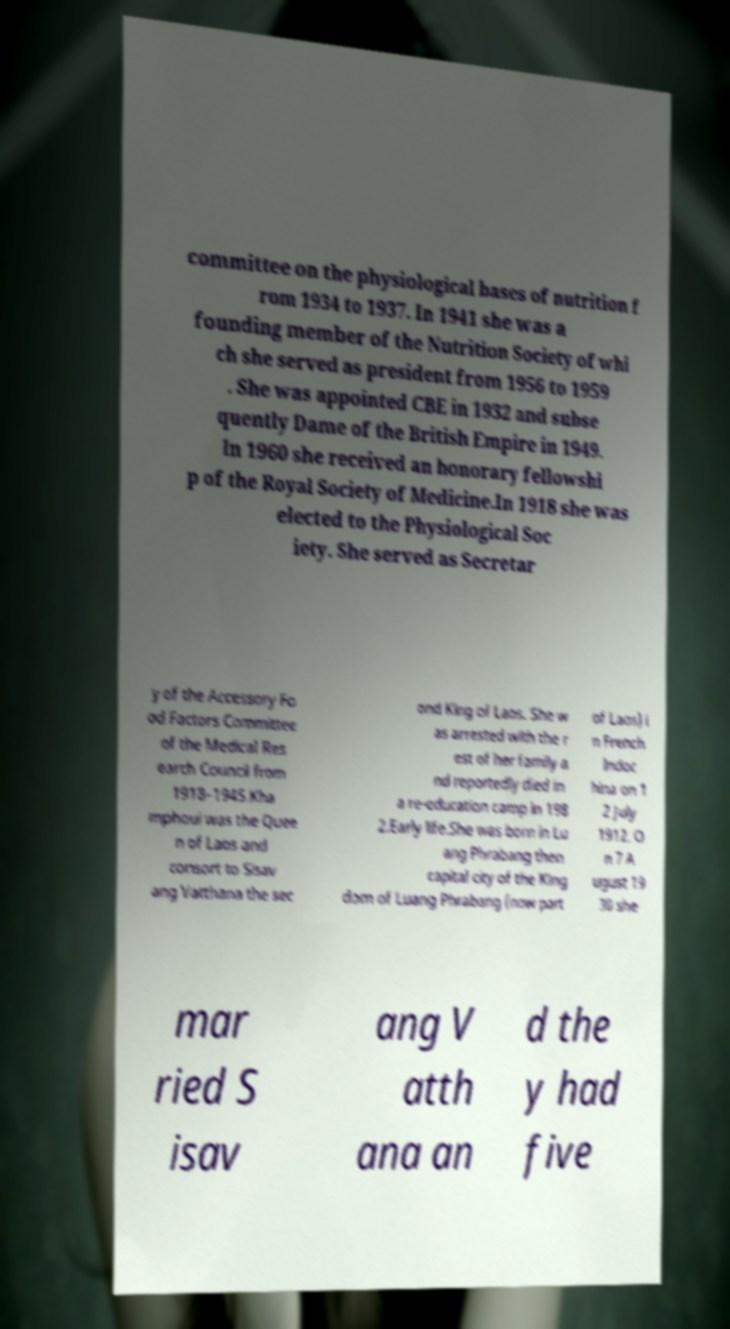What messages or text are displayed in this image? I need them in a readable, typed format. committee on the physiological bases of nutrition f rom 1934 to 1937. In 1941 she was a founding member of the Nutrition Society of whi ch she served as president from 1956 to 1959 . She was appointed CBE in 1932 and subse quently Dame of the British Empire in 1949. In 1960 she received an honorary fellowshi p of the Royal Society of Medicine.In 1918 she was elected to the Physiological Soc iety. She served as Secretar y of the Accessory Fo od Factors Committee of the Medical Res earch Council from 1918–1945.Kha mphoui was the Quee n of Laos and consort to Sisav ang Vatthana the sec ond King of Laos. She w as arrested with the r est of her family a nd reportedly died in a re-education camp in 198 2.Early life.She was born in Lu ang Phrabang then capital city of the King dom of Luang Phrabang (now part of Laos) i n French Indoc hina on 1 2 July 1912. O n 7 A ugust 19 30 she mar ried S isav ang V atth ana an d the y had five 